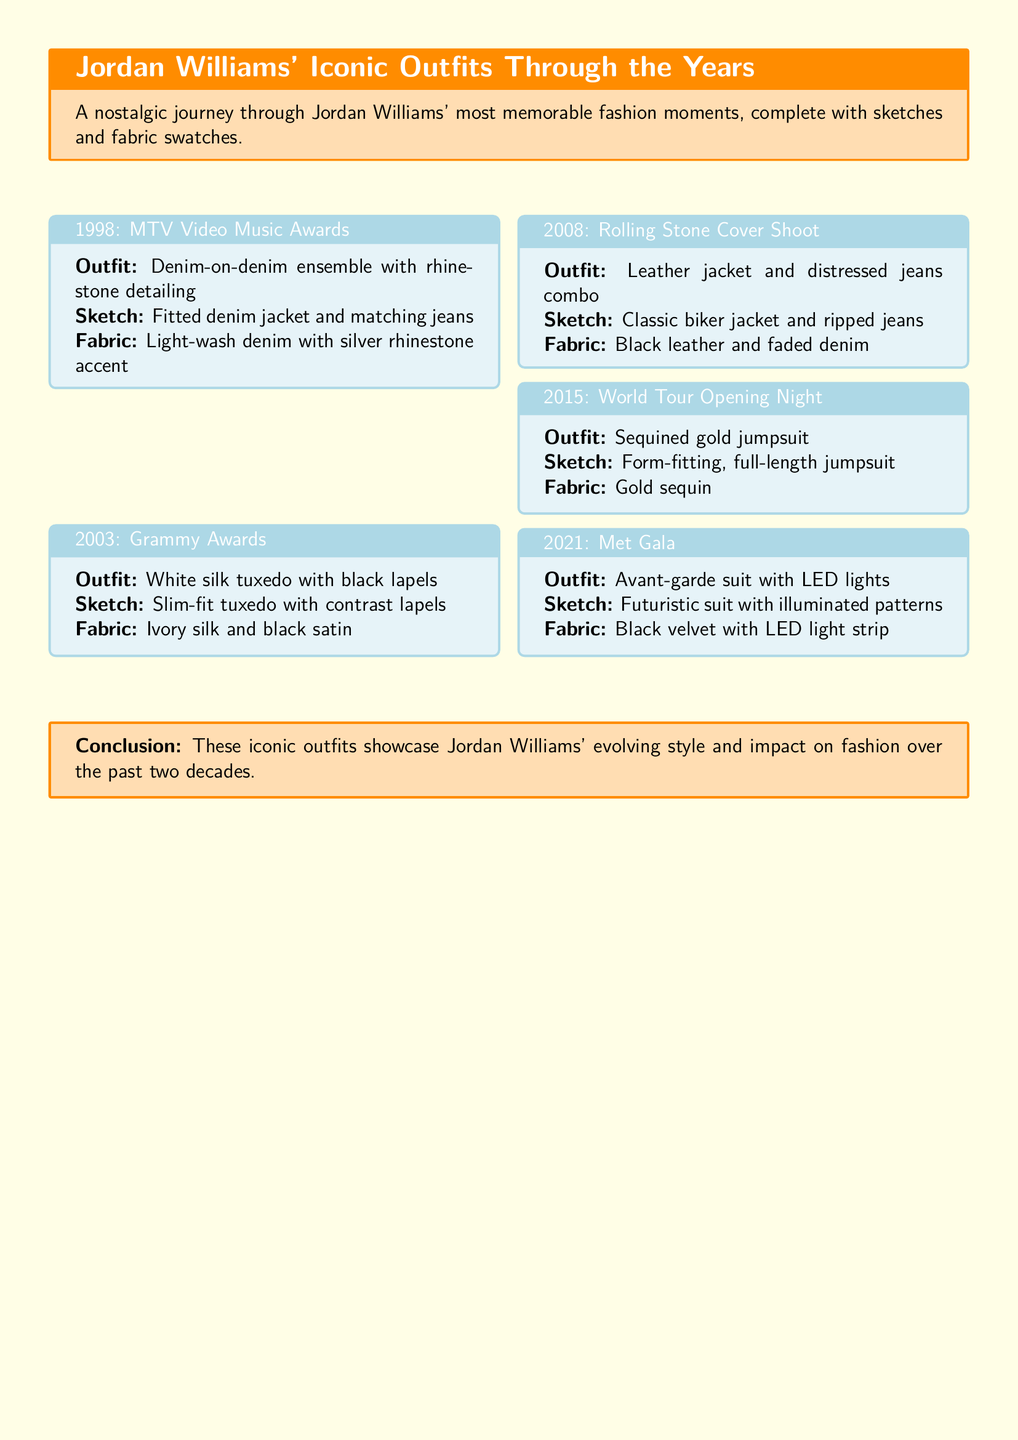What year did Jordan Williams wear a denim-on-denim outfit? The denim-on-denim outfit was worn in 1998 during the MTV Video Music Awards.
Answer: 1998 What type of fabric was used for the 2003 Grammy Awards tuxedo? The tuxedo featured ivory silk and black satin fabric.
Answer: Ivory silk and black satin What is the description of the outfit worn during the 2015 World Tour Opening Night? The description states the outfit was a sequined gold jumpsuit.
Answer: Sequined gold jumpsuit How many outfits are mentioned in the document? There are a total of five iconic outfits listed throughout the years.
Answer: Five Which event featured an avant-garde suit with LED lights? The avant-garde suit with LED lights was featured at the Met Gala in 2021.
Answer: Met Gala Compare the years with the most and least memorable outfits mentioned in the document. 2021 (Met Gala) with the avant-garde suit is the most recent, while 1998 (MTV Video Music Awards) features the first iconic outfit, which can be considered the least in terms of recency.
Answer: 2021 and 1998 What is the conclusion about Jordan Williams' iconic outfits? The conclusion states these outfits showcase his evolving style and impact on fashion over the past two decades.
Answer: Evolving style and impact on fashion What sketch type describes the 2008 Rolling Stone Cover Shoot outfit? The sketch depicts a classic biker jacket and ripped jeans.
Answer: Classic biker jacket and ripped jeans 